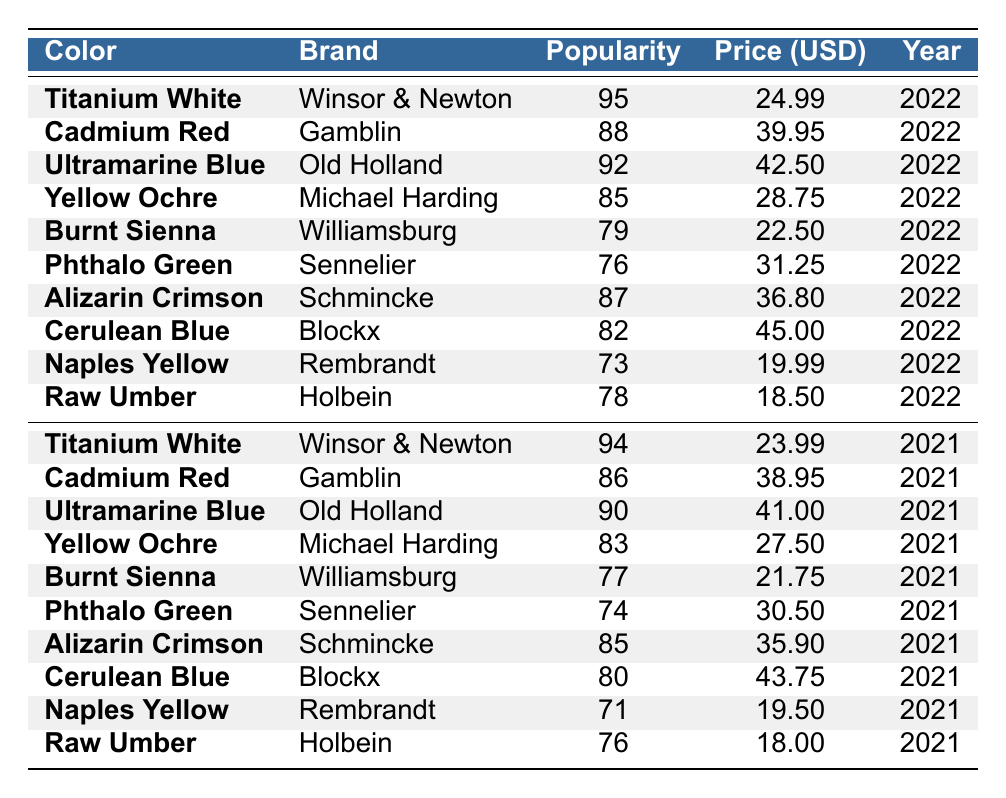What is the most popular oil paint color in 2022? The color with the highest popularity score in 2022 is Titanium White with a score of 95.
Answer: Titanium White Which brand produces Cadmium Red? The brand associated with Cadmium Red is Gamblin.
Answer: Gamblin What is the average price of Ultramarine Blue across the two years? The prices for Ultramarine Blue are $42.50 in 2022 and $41.00 in 2021. The average price is (42.50 + 41.00) / 2 = 41.75.
Answer: 41.75 Is Yellow Ochre cheaper than Burnt Sienna in 2021? The price of Yellow Ochre in 2021 is $27.50, and the price of Burnt Sienna is $21.75. Since $27.50 is greater than $21.75, Yellow Ochre is not cheaper than Burnt Sienna.
Answer: No What is the difference in popularity score for Alizarin Crimson between 2021 and 2022? The popularity score of Alizarin Crimson in 2022 is 87, and in 2021 it is 85. The difference is 87 - 85 = 2.
Answer: 2 Which color has the lowest popularity score in 2022? The lowest popularity score in 2022 is for Naples Yellow, with a score of 73.
Answer: Naples Yellow Average the popularity scores for colors that have the same brand in both years. The brands with presence in both years are Winsor & Newton and Gamblin. For Winsor & Newton: (95 + 94) / 2 = 94.5; for Gamblin: (88 + 86) / 2 = 87. The average popularity scores are 94.5 for Winsor & Newton and 87 for Gamblin.
Answer: Winsor & Newton: 94.5, Gamblin: 87 Is Cerulean Blue more popular in 2021 or 2022? Cerulean Blue has a popularity score of 82 in 2022 and 80 in 2021. Since 82 is greater than 80, Cerulean Blue is more popular in 2022.
Answer: 2022 What is the total average price of all colors listed in 2022? To find the total average price for 2022, add all the prices: (24.99 + 39.95 + 42.50 + 28.75 + 22.50 + 31.25 + 36.80 + 45.00 + 19.99 + 18.50) = 359.24. There are 10 colors, so the average price is 359.24 / 10 = 35.92.
Answer: 35.92 Which color has the highest average price across both years? The prices for Titanium White are $24.99 in 2022 and $23.99 in 2021; for Cadmium Red, they are $39.95 and $38.95, respectively; and for Ultramarine Blue, they are $42.50 and $41.00. The highest average is for Ultramarine Blue: (42.50 + 41.00) / 2 = 41.75.
Answer: Ultramarine Blue 